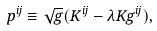Convert formula to latex. <formula><loc_0><loc_0><loc_500><loc_500>p ^ { i j } \equiv \sqrt { g } ( K ^ { i j } - \lambda K g ^ { i j } ) ,</formula> 